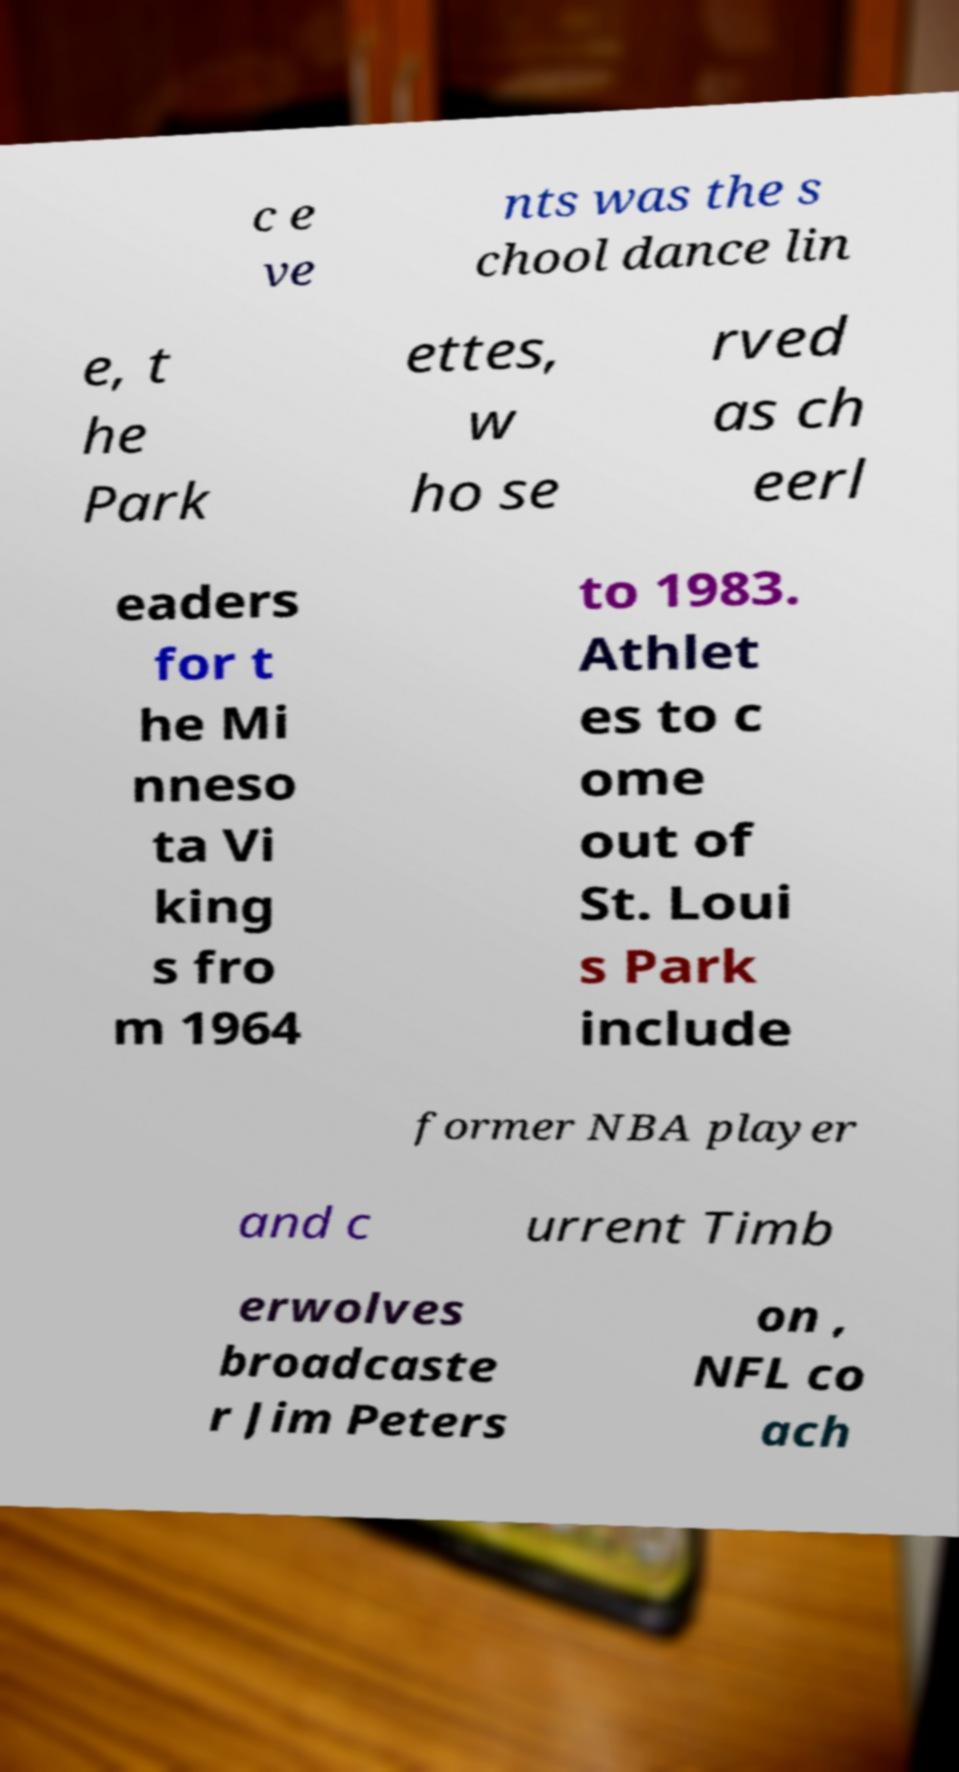What messages or text are displayed in this image? I need them in a readable, typed format. c e ve nts was the s chool dance lin e, t he Park ettes, w ho se rved as ch eerl eaders for t he Mi nneso ta Vi king s fro m 1964 to 1983. Athlet es to c ome out of St. Loui s Park include former NBA player and c urrent Timb erwolves broadcaste r Jim Peters on , NFL co ach 